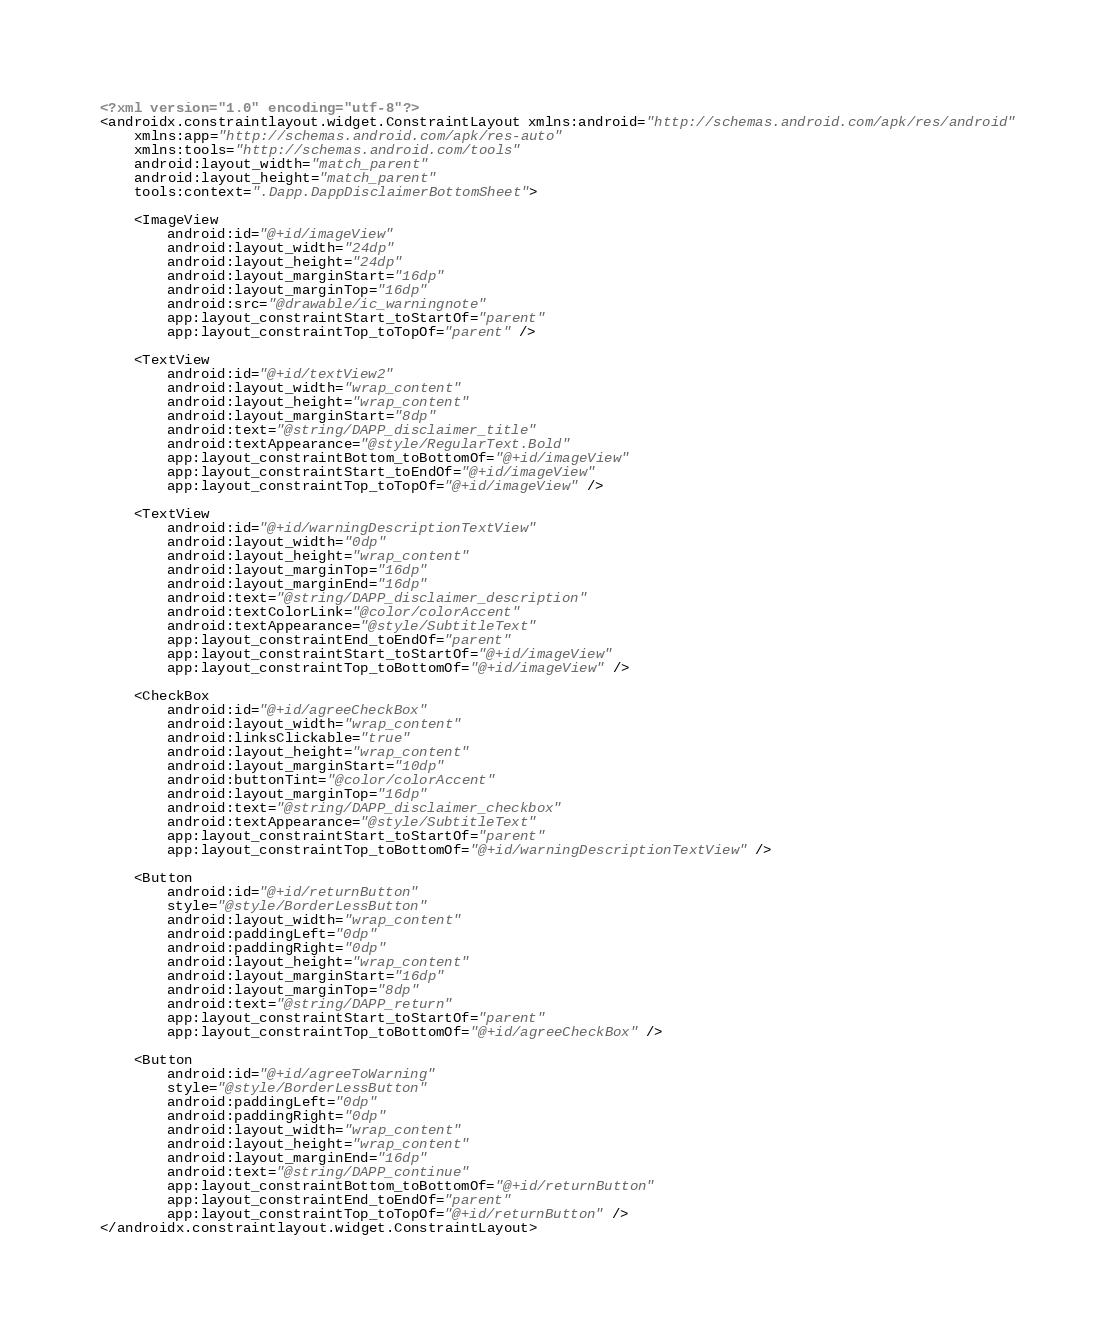<code> <loc_0><loc_0><loc_500><loc_500><_XML_><?xml version="1.0" encoding="utf-8"?>
<androidx.constraintlayout.widget.ConstraintLayout xmlns:android="http://schemas.android.com/apk/res/android"
    xmlns:app="http://schemas.android.com/apk/res-auto"
    xmlns:tools="http://schemas.android.com/tools"
    android:layout_width="match_parent"
    android:layout_height="match_parent"
    tools:context=".Dapp.DappDisclaimerBottomSheet">

    <ImageView
        android:id="@+id/imageView"
        android:layout_width="24dp"
        android:layout_height="24dp"
        android:layout_marginStart="16dp"
        android:layout_marginTop="16dp"
        android:src="@drawable/ic_warningnote"
        app:layout_constraintStart_toStartOf="parent"
        app:layout_constraintTop_toTopOf="parent" />

    <TextView
        android:id="@+id/textView2"
        android:layout_width="wrap_content"
        android:layout_height="wrap_content"
        android:layout_marginStart="8dp"
        android:text="@string/DAPP_disclaimer_title"
        android:textAppearance="@style/RegularText.Bold"
        app:layout_constraintBottom_toBottomOf="@+id/imageView"
        app:layout_constraintStart_toEndOf="@+id/imageView"
        app:layout_constraintTop_toTopOf="@+id/imageView" />

    <TextView
        android:id="@+id/warningDescriptionTextView"
        android:layout_width="0dp"
        android:layout_height="wrap_content"
        android:layout_marginTop="16dp"
        android:layout_marginEnd="16dp"
        android:text="@string/DAPP_disclaimer_description"
        android:textColorLink="@color/colorAccent"
        android:textAppearance="@style/SubtitleText"
        app:layout_constraintEnd_toEndOf="parent"
        app:layout_constraintStart_toStartOf="@+id/imageView"
        app:layout_constraintTop_toBottomOf="@+id/imageView" />

    <CheckBox
        android:id="@+id/agreeCheckBox"
        android:layout_width="wrap_content"
        android:linksClickable="true"
        android:layout_height="wrap_content"
        android:layout_marginStart="10dp"
        android:buttonTint="@color/colorAccent"
        android:layout_marginTop="16dp"
        android:text="@string/DAPP_disclaimer_checkbox"
        android:textAppearance="@style/SubtitleText"
        app:layout_constraintStart_toStartOf="parent"
        app:layout_constraintTop_toBottomOf="@+id/warningDescriptionTextView" />

    <Button
        android:id="@+id/returnButton"
        style="@style/BorderLessButton"
        android:layout_width="wrap_content"
        android:paddingLeft="0dp"
        android:paddingRight="0dp"
        android:layout_height="wrap_content"
        android:layout_marginStart="16dp"
        android:layout_marginTop="8dp"
        android:text="@string/DAPP_return"
        app:layout_constraintStart_toStartOf="parent"
        app:layout_constraintTop_toBottomOf="@+id/agreeCheckBox" />

    <Button
        android:id="@+id/agreeToWarning"
        style="@style/BorderLessButton"
        android:paddingLeft="0dp"
        android:paddingRight="0dp"
        android:layout_width="wrap_content"
        android:layout_height="wrap_content"
        android:layout_marginEnd="16dp"
        android:text="@string/DAPP_continue"
        app:layout_constraintBottom_toBottomOf="@+id/returnButton"
        app:layout_constraintEnd_toEndOf="parent"
        app:layout_constraintTop_toTopOf="@+id/returnButton" />
</androidx.constraintlayout.widget.ConstraintLayout></code> 